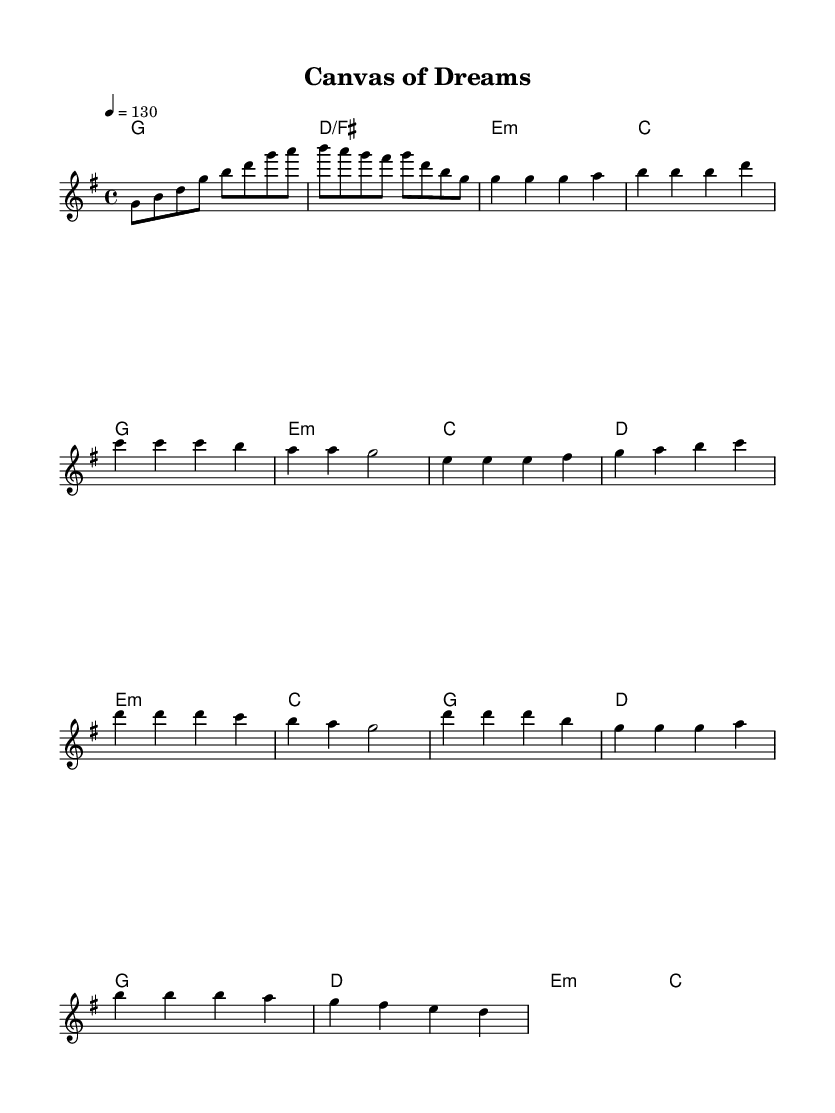What is the key signature of this music? The key signature indicates one sharp, which corresponds to the G major scale.
Answer: G major What is the time signature used in this piece? The time signature is shown at the beginning of the music and is represented as four beats per measure, indicated by the format 4/4.
Answer: 4/4 What is the tempo marking for this music? The tempo marking is specified as quarter note equals 130 beats per minute, indicating a brisk pace for the song.
Answer: 130 In which section does the melody start with two repeated notes? The melody starts with the two repeated notes 'g' indicated in the intro and enters again in the verse section after the introduction.
Answer: Intro How many measures are in the chorus section? Counting the measures in the score, the chorus contains four distinct measures as outlined in the notation right after the pre-chorus.
Answer: 4 What chord is played in the first measure? The first measure indicates a G major chord as per the chord nomenclature shown at the beginning of the score.
Answer: G What musical genre does this piece represent? Analyzing the upbeat tempo, catchy melody, and structured chorus format, this piece represents K-Pop music, known for its vibrant artistry and creativity.
Answer: K-Pop 